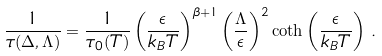<formula> <loc_0><loc_0><loc_500><loc_500>\frac { 1 } { \tau ( \Delta , \Lambda ) } = \frac { 1 } { \tau _ { 0 } ( T ) } \left ( \frac { \epsilon } { k _ { B } T } \right ) ^ { \beta + 1 } \left ( \frac { \Lambda } { \epsilon } \right ) ^ { 2 } \coth \left ( \frac { \epsilon } { k _ { B } T } \right ) \, .</formula> 